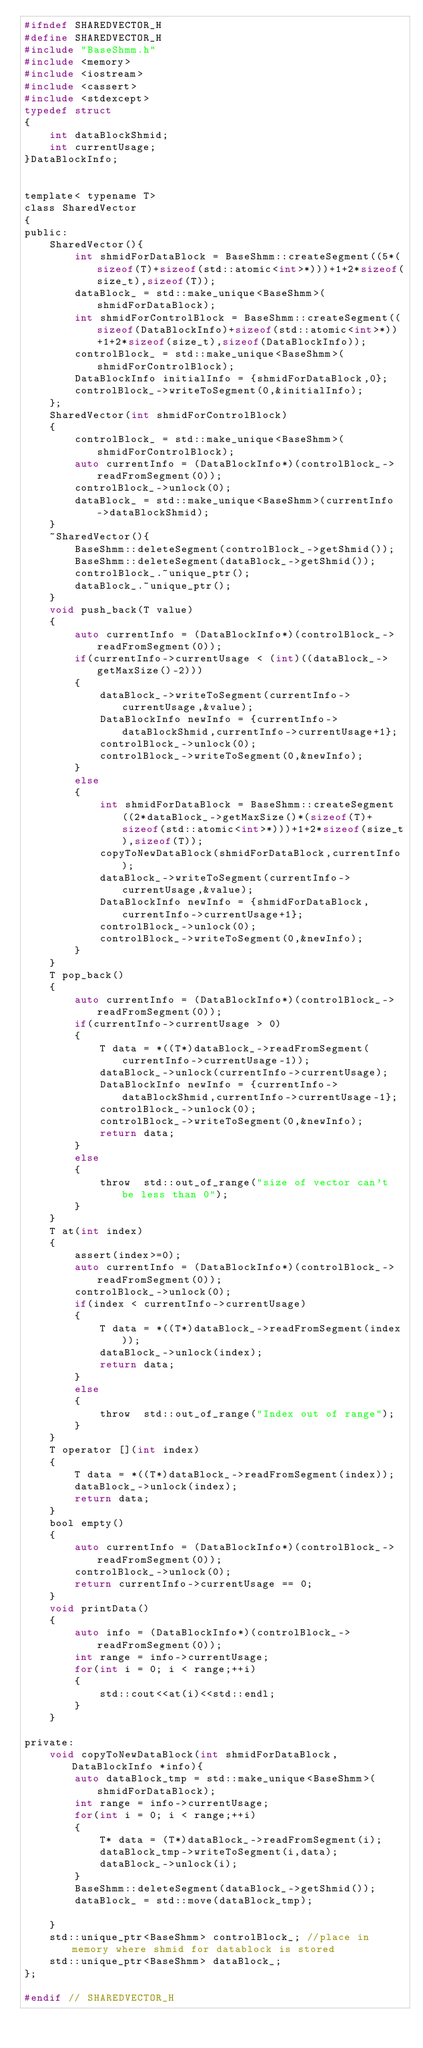Convert code to text. <code><loc_0><loc_0><loc_500><loc_500><_C_>#ifndef SHAREDVECTOR_H
#define SHAREDVECTOR_H
#include "BaseShmm.h"
#include <memory>
#include <iostream>
#include <cassert>
#include <stdexcept>
typedef struct
{
    int dataBlockShmid;
    int currentUsage;
}DataBlockInfo;


template< typename T>
class SharedVector
{
public:
    SharedVector(){
        int shmidForDataBlock = BaseShmm::createSegment((5*(sizeof(T)+sizeof(std::atomic<int>*)))+1+2*sizeof(size_t),sizeof(T));
        dataBlock_ = std::make_unique<BaseShmm>(shmidForDataBlock);
        int shmidForControlBlock = BaseShmm::createSegment((sizeof(DataBlockInfo)+sizeof(std::atomic<int>*))+1+2*sizeof(size_t),sizeof(DataBlockInfo));
        controlBlock_ = std::make_unique<BaseShmm>(shmidForControlBlock);
        DataBlockInfo initialInfo = {shmidForDataBlock,0};
        controlBlock_->writeToSegment(0,&initialInfo);
    };
    SharedVector(int shmidForControlBlock)
    {
        controlBlock_ = std::make_unique<BaseShmm>(shmidForControlBlock);
        auto currentInfo = (DataBlockInfo*)(controlBlock_->readFromSegment(0));
        controlBlock_->unlock(0);
        dataBlock_ = std::make_unique<BaseShmm>(currentInfo->dataBlockShmid);
    }
    ~SharedVector(){
        BaseShmm::deleteSegment(controlBlock_->getShmid());
        BaseShmm::deleteSegment(dataBlock_->getShmid());
        controlBlock_.~unique_ptr();
        dataBlock_.~unique_ptr();
    }
    void push_back(T value)
    {
        auto currentInfo = (DataBlockInfo*)(controlBlock_->readFromSegment(0));
        if(currentInfo->currentUsage < (int)((dataBlock_->getMaxSize()-2)))
        {
            dataBlock_->writeToSegment(currentInfo->currentUsage,&value);
            DataBlockInfo newInfo = {currentInfo->dataBlockShmid,currentInfo->currentUsage+1};
            controlBlock_->unlock(0);
            controlBlock_->writeToSegment(0,&newInfo);
        }
        else
        {
            int shmidForDataBlock = BaseShmm::createSegment((2*dataBlock_->getMaxSize()*(sizeof(T)+sizeof(std::atomic<int>*)))+1+2*sizeof(size_t),sizeof(T));
            copyToNewDataBlock(shmidForDataBlock,currentInfo);
            dataBlock_->writeToSegment(currentInfo->currentUsage,&value);
            DataBlockInfo newInfo = {shmidForDataBlock,currentInfo->currentUsage+1};
            controlBlock_->unlock(0);
            controlBlock_->writeToSegment(0,&newInfo);
        }
    }
    T pop_back()
    {
        auto currentInfo = (DataBlockInfo*)(controlBlock_->readFromSegment(0));
        if(currentInfo->currentUsage > 0)
        {
            T data = *((T*)dataBlock_->readFromSegment(currentInfo->currentUsage-1));
            dataBlock_->unlock(currentInfo->currentUsage);
            DataBlockInfo newInfo = {currentInfo->dataBlockShmid,currentInfo->currentUsage-1};
            controlBlock_->unlock(0);
            controlBlock_->writeToSegment(0,&newInfo);
            return data;
        }
        else
        {
            throw  std::out_of_range("size of vector can't be less than 0");
        }
    }
    T at(int index)
    {
        assert(index>=0);
        auto currentInfo = (DataBlockInfo*)(controlBlock_->readFromSegment(0));
        controlBlock_->unlock(0);
        if(index < currentInfo->currentUsage)
        {
            T data = *((T*)dataBlock_->readFromSegment(index));
            dataBlock_->unlock(index);
            return data;
        }
        else
        {
            throw  std::out_of_range("Index out of range");
        }
    }
    T operator [](int index)
    {
        T data = *((T*)dataBlock_->readFromSegment(index));
        dataBlock_->unlock(index);
        return data;
    }
    bool empty()
    {
        auto currentInfo = (DataBlockInfo*)(controlBlock_->readFromSegment(0));
        controlBlock_->unlock(0);
        return currentInfo->currentUsage == 0;
    }
    void printData()
    {
        auto info = (DataBlockInfo*)(controlBlock_->readFromSegment(0));
        int range = info->currentUsage;
        for(int i = 0; i < range;++i)
        {
            std::cout<<at(i)<<std::endl;
        }
    }

private:
    void copyToNewDataBlock(int shmidForDataBlock,DataBlockInfo *info){
        auto dataBlock_tmp = std::make_unique<BaseShmm>(shmidForDataBlock);
        int range = info->currentUsage;
        for(int i = 0; i < range;++i)
        {
            T* data = (T*)dataBlock_->readFromSegment(i);
            dataBlock_tmp->writeToSegment(i,data);
            dataBlock_->unlock(i);
        }
        BaseShmm::deleteSegment(dataBlock_->getShmid());
        dataBlock_ = std::move(dataBlock_tmp);

    }
    std::unique_ptr<BaseShmm> controlBlock_; //place in memory where shmid for datablock is stored
    std::unique_ptr<BaseShmm> dataBlock_;
};

#endif // SHAREDVECTOR_H
</code> 